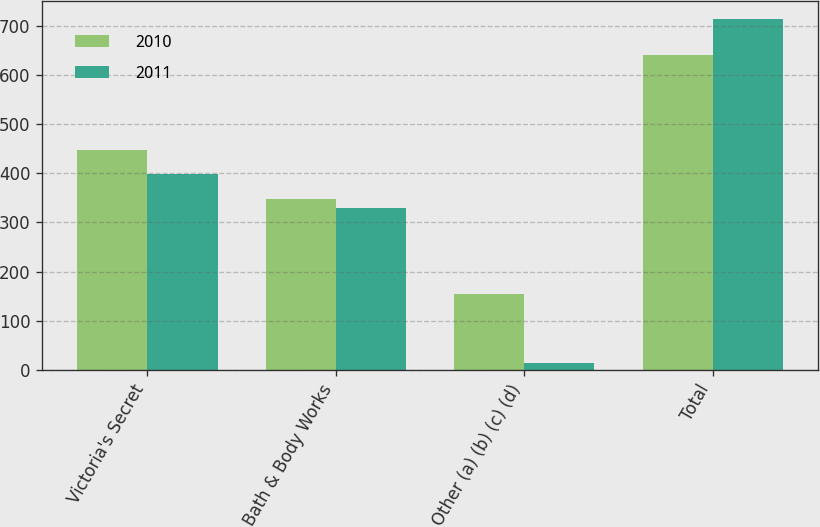Convert chart. <chart><loc_0><loc_0><loc_500><loc_500><stacked_bar_chart><ecel><fcel>Victoria's Secret<fcel>Bath & Body Works<fcel>Other (a) (b) (c) (d)<fcel>Total<nl><fcel>2010<fcel>447<fcel>348<fcel>154<fcel>641<nl><fcel>2011<fcel>398<fcel>330<fcel>14<fcel>714<nl></chart> 